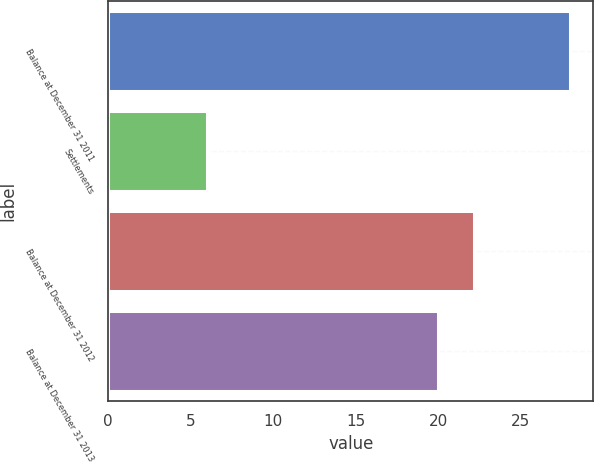<chart> <loc_0><loc_0><loc_500><loc_500><bar_chart><fcel>Balance at December 31 2011<fcel>Settlements<fcel>Balance at December 31 2012<fcel>Balance at December 31 2013<nl><fcel>28<fcel>6<fcel>22.2<fcel>20<nl></chart> 